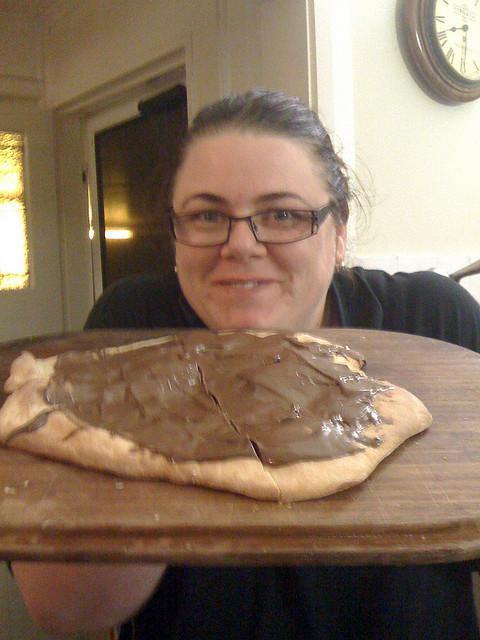Is the given caption "The person is away from the pizza." fitting for the image?
Answer yes or no. No. 